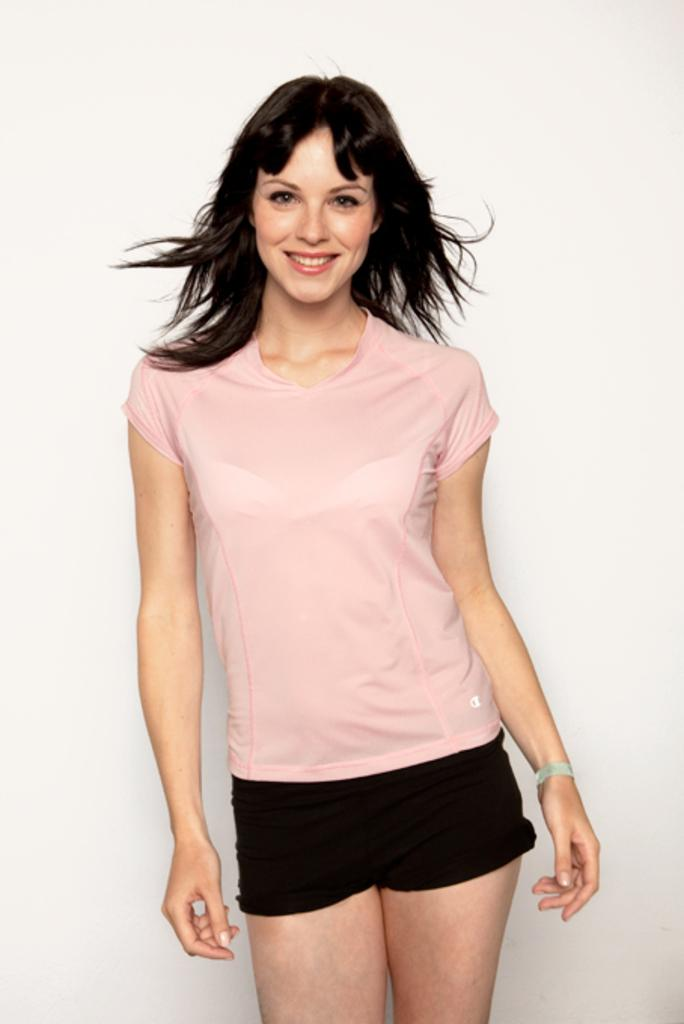Who is the main subject in the foreground of the image? There is a woman in the foreground of the image. What is the woman doing in the image? The woman is standing in the image. What color is the woman's T-shirt? The woman is wearing a pink T-shirt. What expression does the woman has the woman in the image? The woman has a smile on her face. What is the color of the background in the image? The background of the image is white. How many pigs are visible in the image? There are no pigs present in the image. What type of love is the woman expressing in the image? The image does not depict any specific type of love; it simply shows a woman with a smile on her face. 